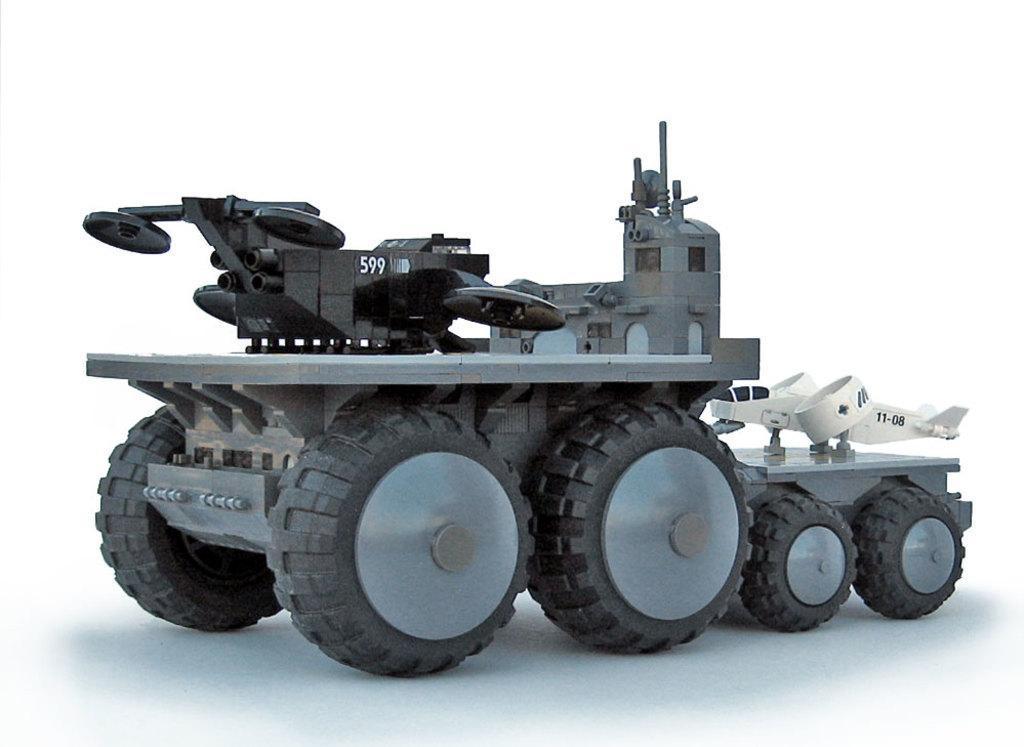Please provide a concise description of this image. Here we can see a vehicle and there is a white background. 